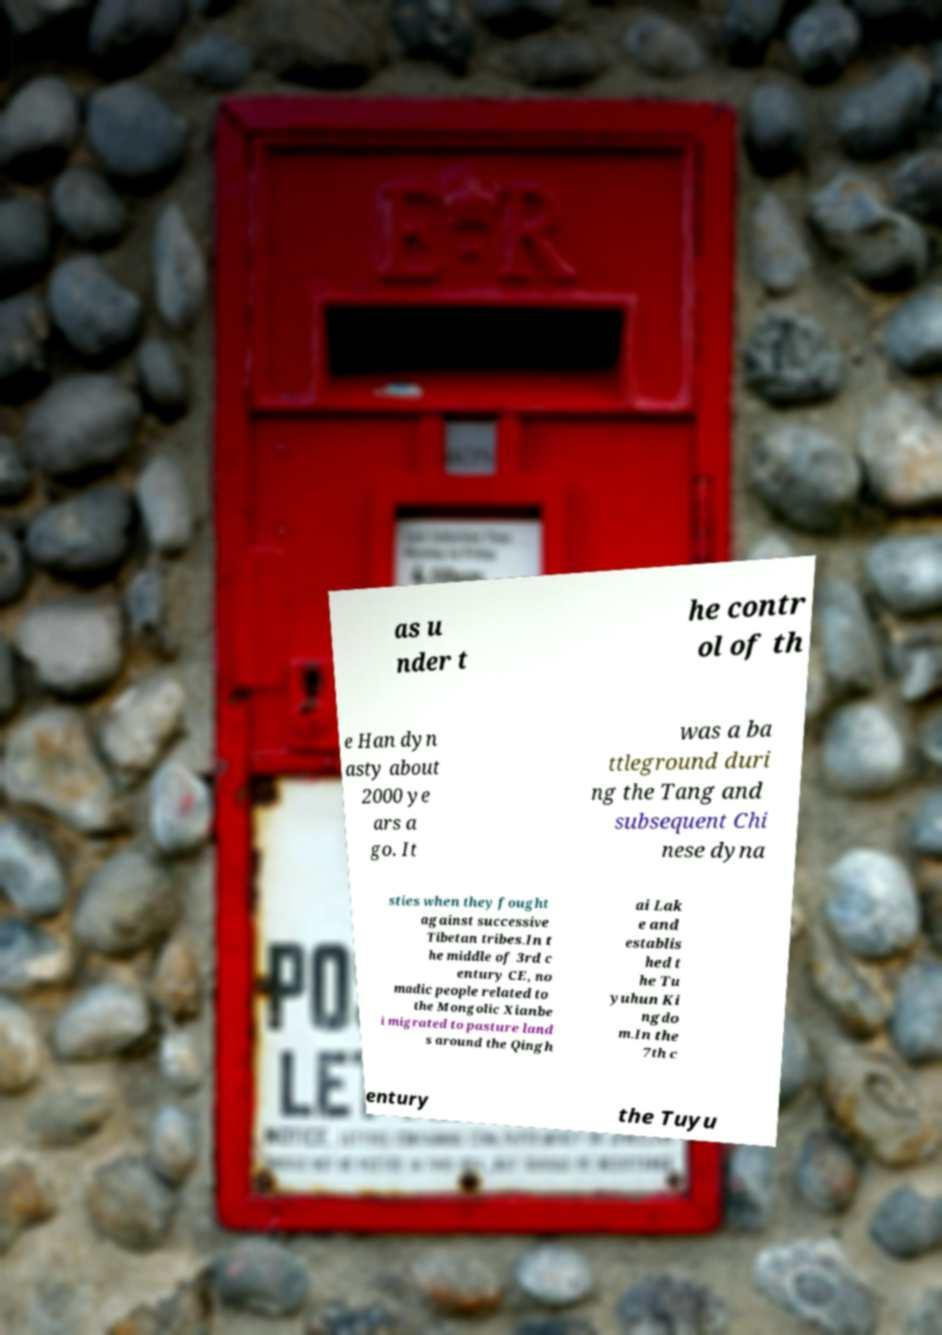There's text embedded in this image that I need extracted. Can you transcribe it verbatim? as u nder t he contr ol of th e Han dyn asty about 2000 ye ars a go. It was a ba ttleground duri ng the Tang and subsequent Chi nese dyna sties when they fought against successive Tibetan tribes.In t he middle of 3rd c entury CE, no madic people related to the Mongolic Xianbe i migrated to pasture land s around the Qingh ai Lak e and establis hed t he Tu yuhun Ki ngdo m.In the 7th c entury the Tuyu 